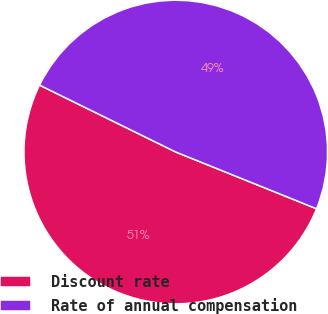Convert chart. <chart><loc_0><loc_0><loc_500><loc_500><pie_chart><fcel>Discount rate<fcel>Rate of annual compensation<nl><fcel>51.17%<fcel>48.83%<nl></chart> 